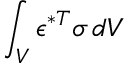<formula> <loc_0><loc_0><loc_500><loc_500>\int _ { V } { \epsilon } ^ { * T } { \sigma } \, d V</formula> 